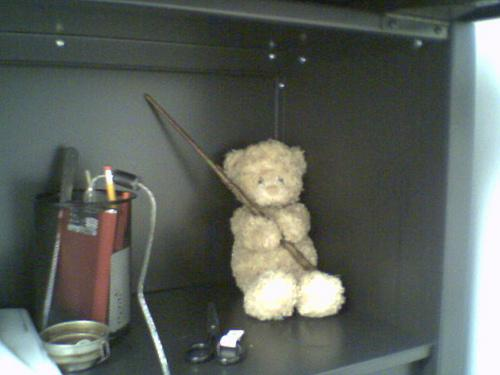Question: how many scissors are there?
Choices:
A. 6.
B. 4.
C. 1.
D. 8.
Answer with the letter. Answer: C Question: what is the teddy having in his hands?
Choices:
A. Stick.
B. Ball.
C. Net.
D. Wand.
Answer with the letter. Answer: A Question: where is the pencil?
Choices:
A. In the stand.
B. In the drawer.
C. In the cup.
D. On the desk.
Answer with the letter. Answer: A 